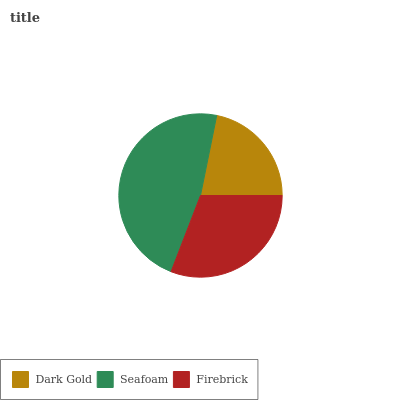Is Dark Gold the minimum?
Answer yes or no. Yes. Is Seafoam the maximum?
Answer yes or no. Yes. Is Firebrick the minimum?
Answer yes or no. No. Is Firebrick the maximum?
Answer yes or no. No. Is Seafoam greater than Firebrick?
Answer yes or no. Yes. Is Firebrick less than Seafoam?
Answer yes or no. Yes. Is Firebrick greater than Seafoam?
Answer yes or no. No. Is Seafoam less than Firebrick?
Answer yes or no. No. Is Firebrick the high median?
Answer yes or no. Yes. Is Firebrick the low median?
Answer yes or no. Yes. Is Seafoam the high median?
Answer yes or no. No. Is Seafoam the low median?
Answer yes or no. No. 